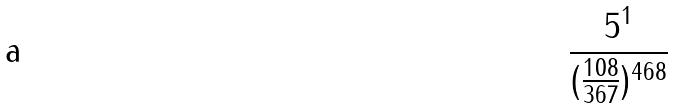<formula> <loc_0><loc_0><loc_500><loc_500>\frac { 5 ^ { 1 } } { ( \frac { 1 0 8 } { 3 6 7 } ) ^ { 4 6 8 } }</formula> 